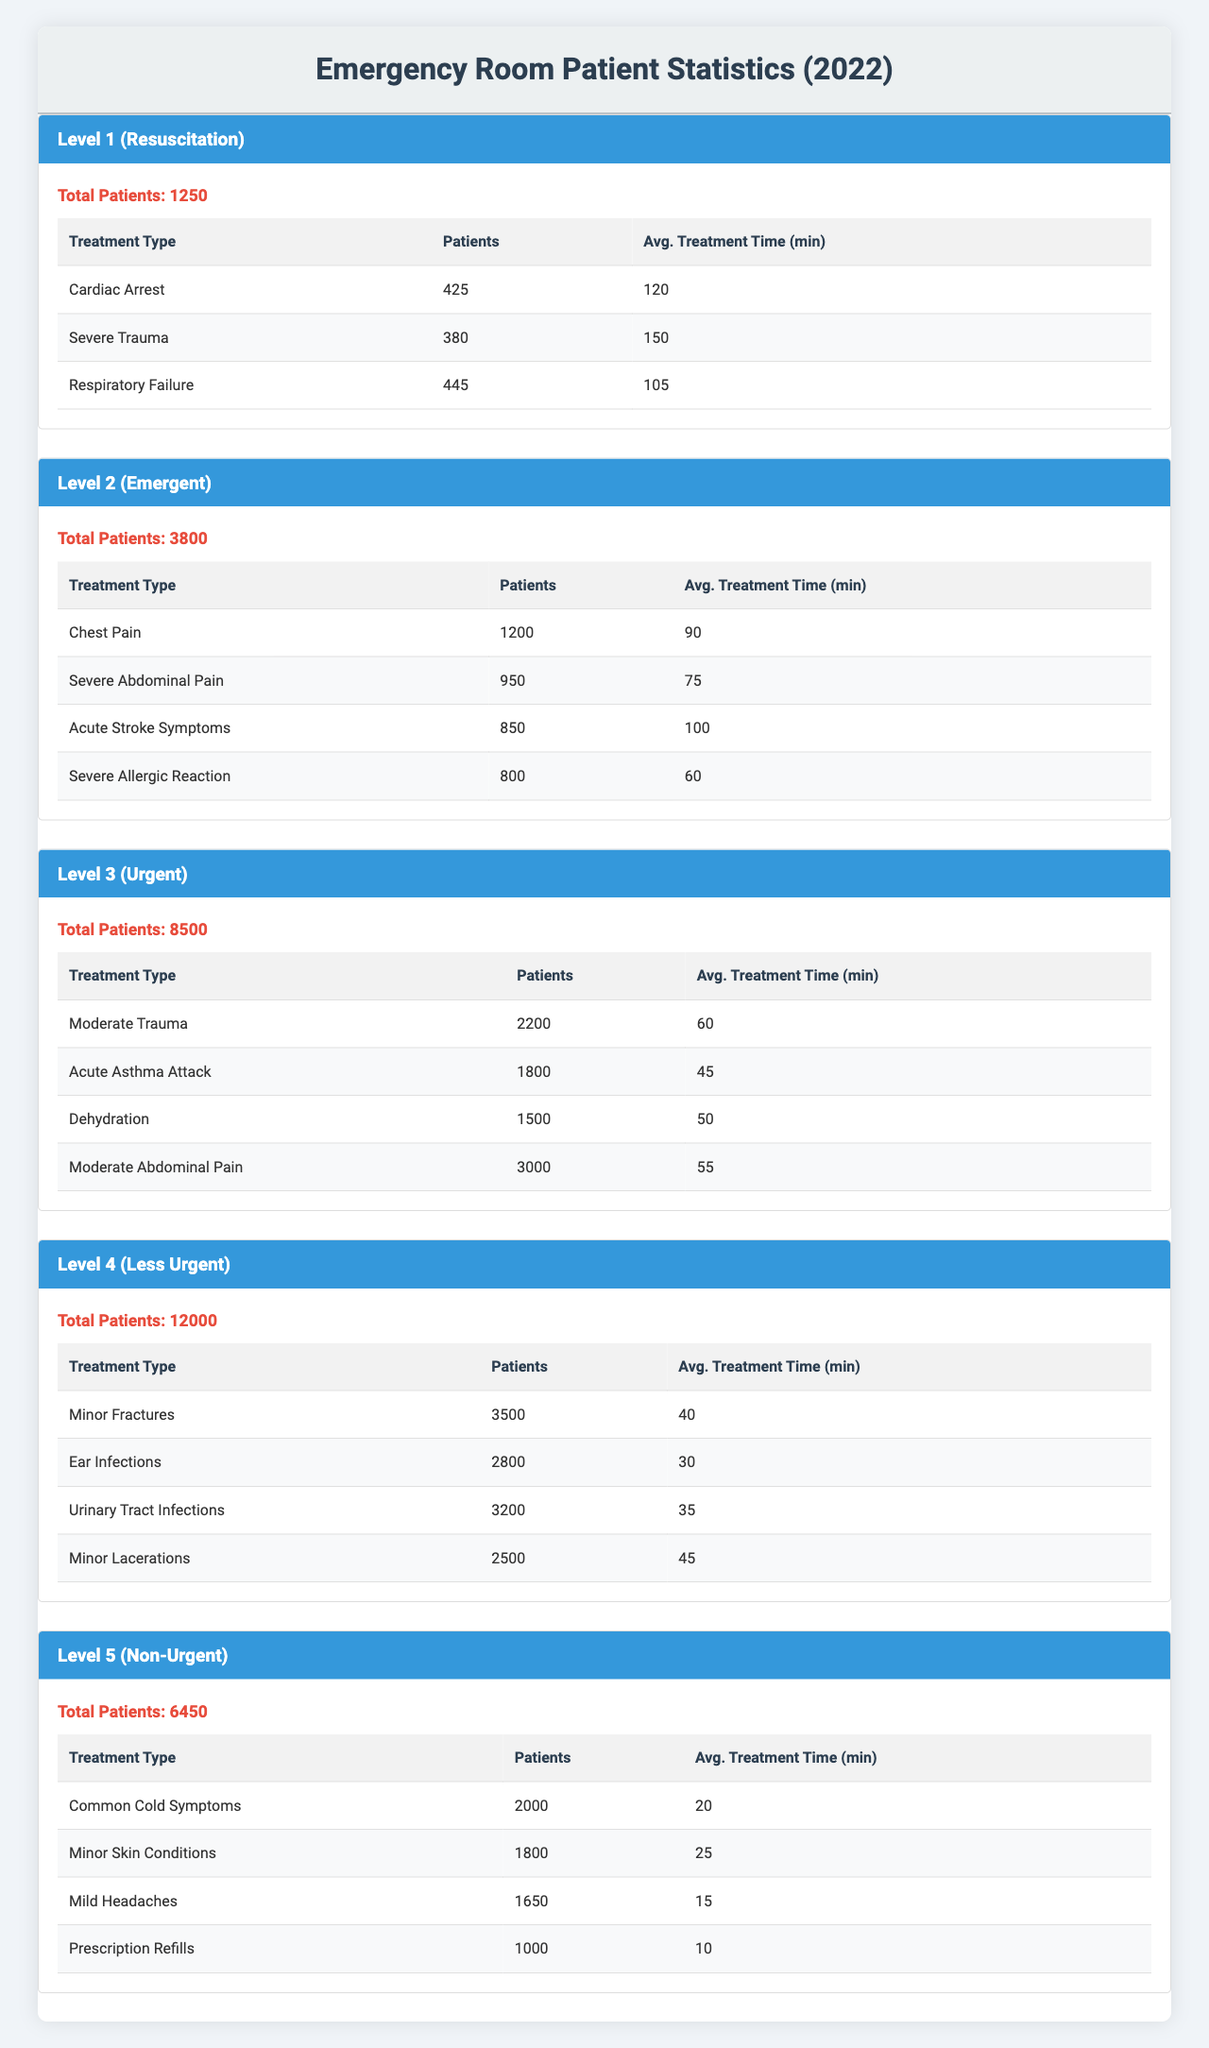What is the total number of patients in Level 1 triage? The table indicates that the total number of patients in Level 1 (Resuscitation) is explicitly listed as 1250.
Answer: 1250 Which treatment type has the highest average treatment time in Level 2 triage? By inspecting the treatment types in Level 2 triage, we see "Severe Abdominal Pain" has the highest average treatment time of 75 minutes.
Answer: Severe Abdominal Pain How many patients were treated for Minor Lacerations in Level 4 triage? The table states that there were 2500 patients treated for Minor Lacerations in Level 4 (Less Urgent) triage.
Answer: 2500 What is the average treatment time for patients in Level 3 triage? To find the average for Level 3, we consider the treatment times: 60, 45, 50, and 55 minutes. Thus, the average is (60 + 45 + 50 + 55) / 4 = 52.5 minutes.
Answer: 52.5 minutes Which triage level had the most total patients? A quick look at the total patient counts shows Level 4 (Less Urgent) with 12000 patients, which is higher than any other level.
Answer: Level 4 (Less Urgent) How many patients were treated for Severe Trauma in Level 1 triage? According to the data, there are 380 patients treated for Severe Trauma in Level 1 (Resuscitation) triage.
Answer: 380 Is the total number of patients in Level 5 greater than 6000? Yes, the table indicates that there were 6450 patients in Level 5 triage, which is greater than 6000.
Answer: Yes What is the difference in total patients between Level 4 and Level 5 triage? Level 4 has 12000 patients and Level 5 has 6450 patients; the difference is 12000 - 6450 = 5550 patients.
Answer: 5550 Calculate the total number of patients treated in Level 2 triage for acute stroke symptoms and severe allergic reaction. The number of patients for acute stroke symptoms is 850 and for severe allergic reaction is 800. Thus, the total is 850 + 800 = 1650 patients.
Answer: 1650 Which treatment type has the least number of patients in Level 3 triage? In Level 3 triage, the treatment with the least number of patients is "Acute Asthma Attack" with a total of 1800 patients.
Answer: Acute Asthma Attack What is the total average treatment time for all treatment types in Level 1 triage? Adding the average treatment times in Level 1: 120 + 150 + 105, we get 375 minutes. With 3 treatment types, the average is 375 / 3 = 125 minutes.
Answer: 125 minutes In which triage level is Respiratory Failure treated, and how many patients were involved? Respiratory Failure is treated in Level 1 (Resuscitation) triage, with a total of 445 patients.
Answer: Level 1 (Resuscitation), 445 patients How many total patients were treated in all triage levels combined? Summing up total patients across all levels: 1250 (Level 1) + 3800 (Level 2) + 8500 (Level 3) + 12000 (Level 4) + 6450 (Level 5) equals 30,000 patients in total.
Answer: 30000 Determine whether the number of patients treated for Common Cold Symptoms in Level 5 exceeds 2500. The table states there were 2000 patients treated for Common Cold Symptoms in Level 5, which does not exceed 2500.
Answer: No 